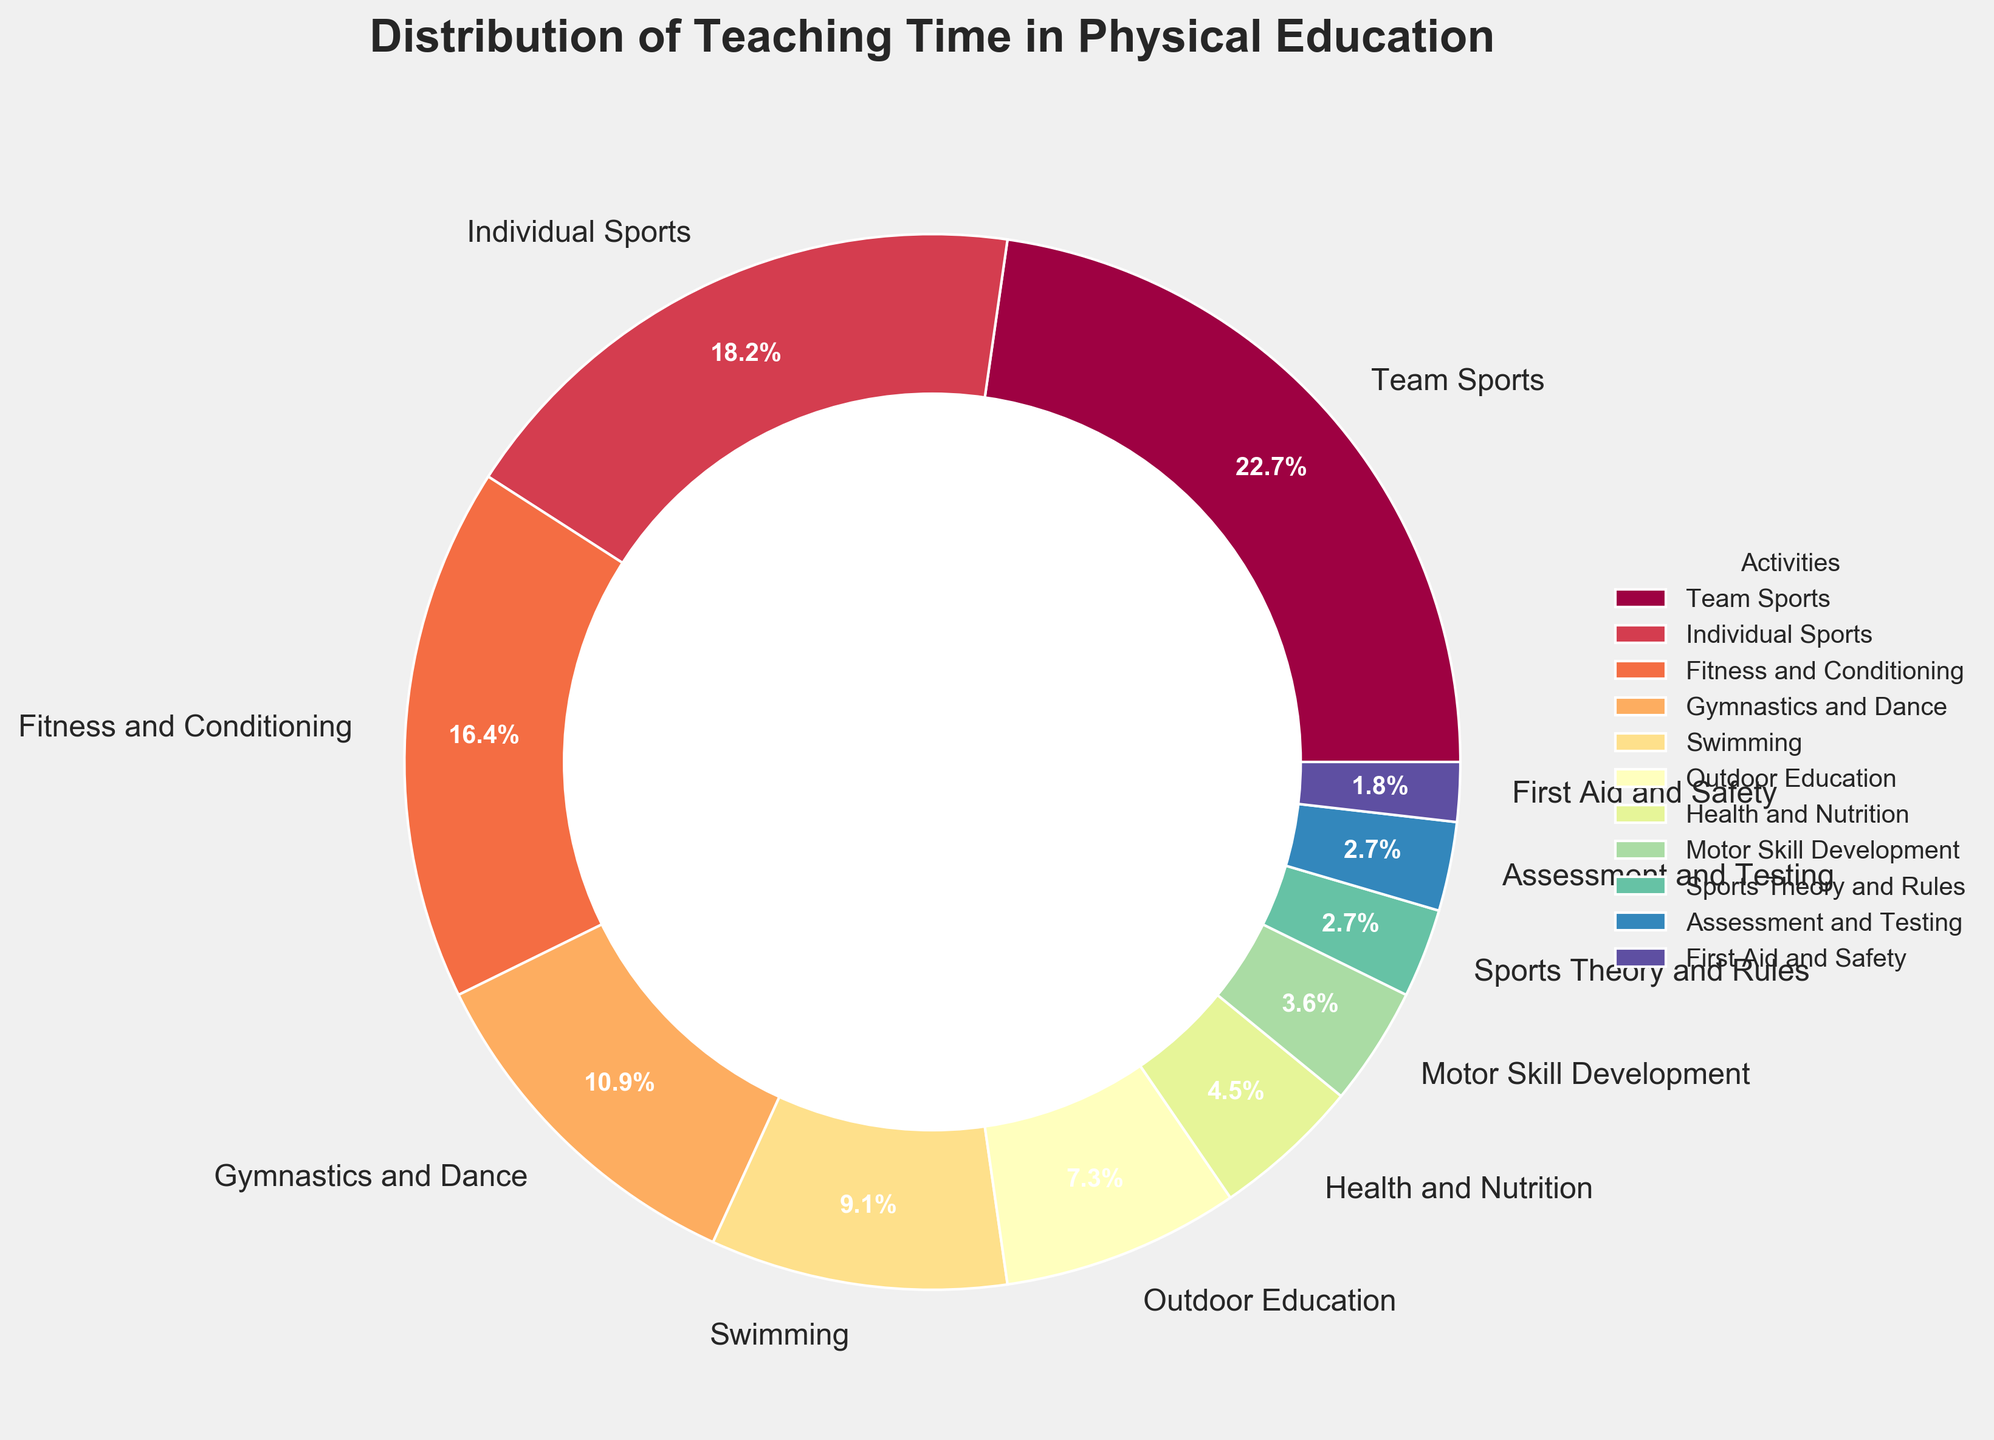What percentage of teaching time is spent on Team Sports? The pie chart shows that Team Sports is labeled with a percentage. Identifying the label for Team Sports provides the answer.
Answer: 25% How much more teaching time is spent on Individual Sports compared to Health and Nutrition? To find this, identify the percentages for both Individual Sports and Health and Nutrition and subtract the smaller value from the larger one. Individual Sports accounts for 20%, and Health and Nutrition accounts for 5%. So, 20% - 5% = 15%.
Answer: 15% Which activity occupies the least percentage of teaching time? By examining the pie chart, find the activity with the smallest percentage label. The smallest percentage label is assigned to First Aid and Safety.
Answer: First Aid and Safety If Fitness and Conditioning and Outdoor Education were combined, what would be their total percentage? Identify the percentages for both Fitness and Conditioning and Outdoor Education. Add these two values together: 18% (Fitness and Conditioning) + 8% (Outdoor Education) = 26%.
Answer: 26% Which three activities together make up the largest portion of teaching time? Find the three activities with the highest percentages and sum those values. Team Sports = 25%, Individual Sports = 20%, and Fitness and Conditioning = 18%. Their total is 25% + 20% + 18% = 63%.
Answer: Team Sports, Individual Sports, Fitness and Conditioning How does the percentage of time spent on Gymnastics and Dance compare to Swimming? Identify the percentages for both Gymnastics and Dance (12%) and Swimming (10%). Subtract the smaller value from the larger one: 12% - 10% = 2%. Therefore, Gymnastics and Dance occupies 2% more time.
Answer: 2% more What is the combined percentage for activities related to health (Health and Nutrition, First Aid and Safety)? Sum the percentages of activities labeled as related to health. Health and Nutrition = 5%, First Aid and Safety = 2%. Their total is 5% + 2% = 7%.
Answer: 7% Which visual attribute helps indicate that Team Sports occupies the largest portion of the pie chart? The visual attribute of interest is the size of the wedge representing Team Sports in relation to others. Team Sports has the largest wedge.
Answer: Largest wedge 